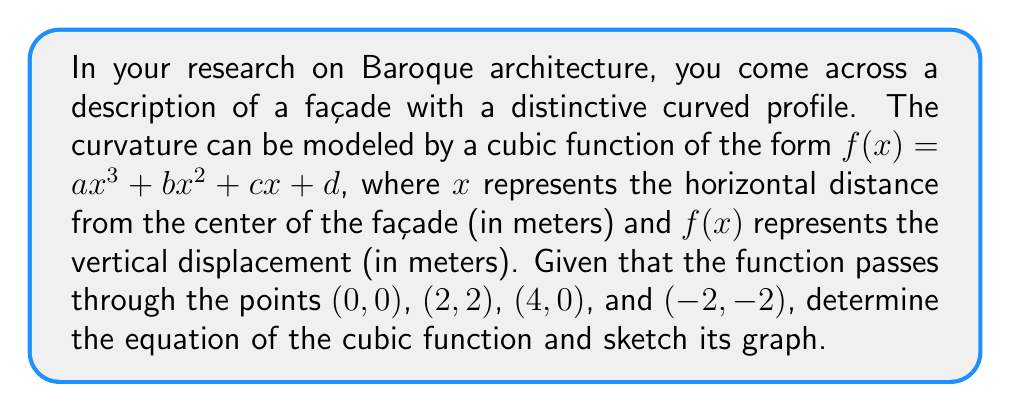What is the answer to this math problem? 1. We know the cubic function has the form $f(x) = ax^3 + bx^2 + cx + d$.

2. Using the given points, we can create a system of equations:
   (0, 0): $d = 0$
   (2, 2): $8a + 4b + 2c = 2$
   (4, 0): $64a + 16b + 4c = 0$
   (-2, -2): $-8a + 4b - 2c = -2$

3. From the first equation, we know $d = 0$. Now we have three equations with three unknowns.

4. Subtracting the third equation from the second:
   $-56a - 12b - 2c = 2$

5. Adding this to the fourth equation:
   $-64a - 8b - 4c = 0$
   $8a + b + \frac{1}{2}c = 0$ (divided by -8)

6. From step 2, second equation:
   $8a + 4b + 2c = 2$

7. Subtracting the equation in step 5 from this:
   $3b + \frac{3}{2}c = 2$
   $2b + c = \frac{4}{3}$

8. From step 2, fourth equation:
   $-8a + 4b - 2c = -2$
   $-2a + b - \frac{1}{2}c = -\frac{1}{2}$ (divided by 4)

9. Combining equations from steps 5 and 8:
   $6a + 2c = \frac{1}{2}$
   $a + \frac{1}{3}c = \frac{1}{12}$

10. Substituting this into the equation from step 5:
    $8(\frac{1}{12} - \frac{1}{3}c) + b + \frac{1}{2}c = 0$
    $\frac{2}{3} - \frac{8}{3}c + b + \frac{1}{2}c = 0$
    $b = -\frac{2}{3} + \frac{13}{6}c$

11. Substituting this into the equation from step 7:
    $2(-\frac{2}{3} + \frac{13}{6}c) + c = \frac{4}{3}$
    $-\frac{4}{3} + \frac{13}{3}c + c = \frac{4}{3}$
    $\frac{16}{3}c = \frac{8}{3}$
    $c = \frac{1}{2}$

12. Substituting back:
    $b = -\frac{2}{3} + \frac{13}{12} = -\frac{1}{12}$
    $a = \frac{1}{12} - \frac{1}{6} = -\frac{1}{12}$

Therefore, the cubic function is:
$f(x) = -\frac{1}{12}x^3 - \frac{1}{12}x^2 + \frac{1}{2}x$

To sketch the graph:
[asy]
import graph;
size(200,200);
real f(real x) {return -1/12*x^3 - 1/12*x^2 + 1/2*x;}
draw(graph(f,-4,4),blue);
xaxis("x",-4,4,arrow=Arrow);
yaxis("y",-3,3,arrow=Arrow);
dot((0,0));
dot((2,2));
dot((4,0));
dot((-2,-2));
label("(0,0)",(0,0),SE);
label("(2,2)",(2,2),NE);
label("(4,0)",(4,0),SE);
label("(-2,-2)",(-2,-2),SW);
[/asy]
Answer: $f(x) = -\frac{1}{12}x^3 - \frac{1}{12}x^2 + \frac{1}{2}x$ 